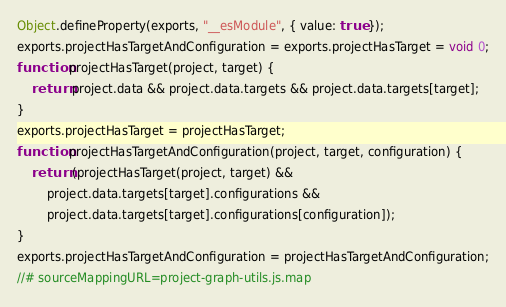<code> <loc_0><loc_0><loc_500><loc_500><_JavaScript_>Object.defineProperty(exports, "__esModule", { value: true });
exports.projectHasTargetAndConfiguration = exports.projectHasTarget = void 0;
function projectHasTarget(project, target) {
    return project.data && project.data.targets && project.data.targets[target];
}
exports.projectHasTarget = projectHasTarget;
function projectHasTargetAndConfiguration(project, target, configuration) {
    return (projectHasTarget(project, target) &&
        project.data.targets[target].configurations &&
        project.data.targets[target].configurations[configuration]);
}
exports.projectHasTargetAndConfiguration = projectHasTargetAndConfiguration;
//# sourceMappingURL=project-graph-utils.js.map</code> 